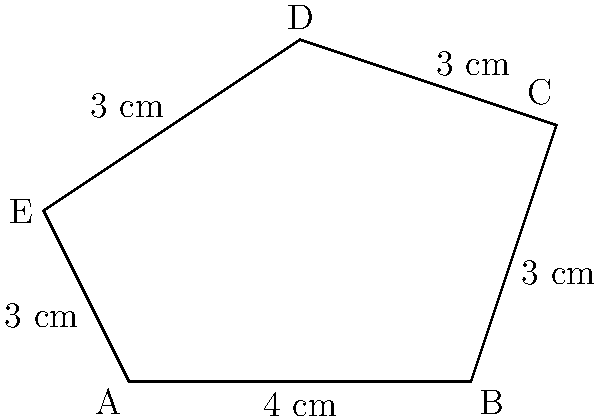A surgeon is planning an incision for a complex surgical procedure. The surgical site is represented by an irregular pentagon ABCDE, as shown in the diagram. Given that AB = 4 cm and the lengths of the other four sides are all 3 cm each, calculate the total perimeter of the surgical site in centimeters. To calculate the perimeter of the irregular pentagon ABCDE, we need to sum up the lengths of all its sides. Let's break it down step by step:

1. Identify the given information:
   - Side AB = 4 cm
   - Sides BC, CD, DE, and EA are all 3 cm each

2. Sum up all the side lengths:
   $$\text{Perimeter} = AB + BC + CD + DE + EA$$
   $$\text{Perimeter} = 4 \text{ cm} + 3 \text{ cm} + 3 \text{ cm} + 3 \text{ cm} + 3 \text{ cm}$$

3. Perform the addition:
   $$\text{Perimeter} = 4 \text{ cm} + 12 \text{ cm} = 16 \text{ cm}$$

Therefore, the total perimeter of the surgical site represented by the irregular pentagon ABCDE is 16 cm.
Answer: 16 cm 